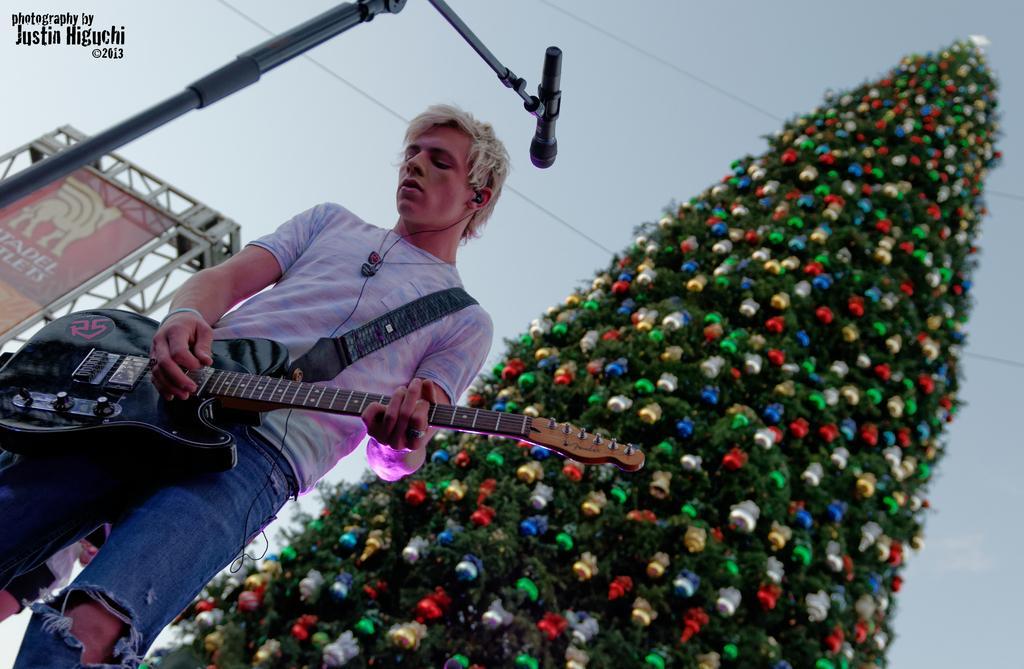Describe this image in one or two sentences. In this image I see a man who is standing in front of a mic and he is holding a guitar. In the background I see a tree which is decorated. 